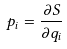<formula> <loc_0><loc_0><loc_500><loc_500>p _ { i } = \frac { \partial S } { \partial q _ { i } }</formula> 